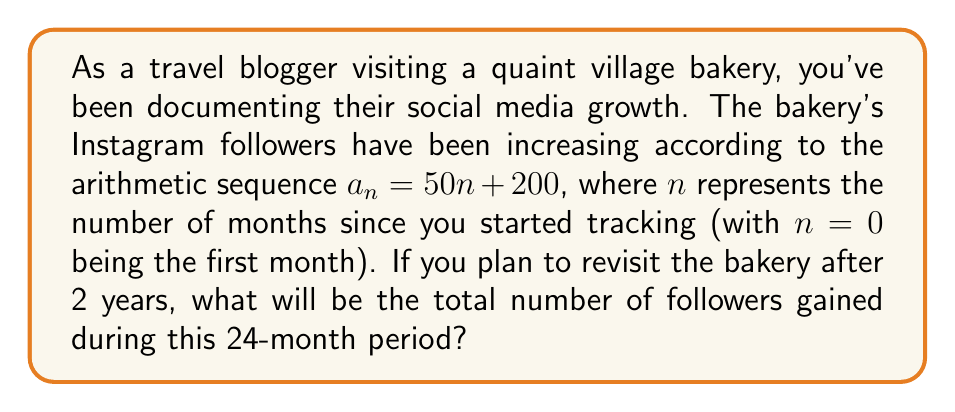Show me your answer to this math problem. Let's approach this step-by-step:

1) The sequence is given by $a_n = 50n + 200$, where $a_n$ represents the number of new followers in the $n$-th month.

2) We need to find the sum of this sequence from $n = 0$ to $n = 23$ (24 months in total).

3) This is an arithmetic sequence with:
   First term $a_0 = 200$
   Last term $a_{23} = 50(23) + 200 = 1350$
   Number of terms $= 24$

4) The sum of an arithmetic sequence is given by:
   $$S_n = \frac{n}{2}(a_1 + a_n)$$
   where $n$ is the number of terms, $a_1$ is the first term, and $a_n$ is the last term.

5) Substituting our values:
   $$S_{24} = \frac{24}{2}(200 + 1350)$$

6) Simplifying:
   $$S_{24} = 12(1550) = 18,600$$

Therefore, the total number of followers gained over the 24-month period is 18,600.
Answer: 18,600 followers 